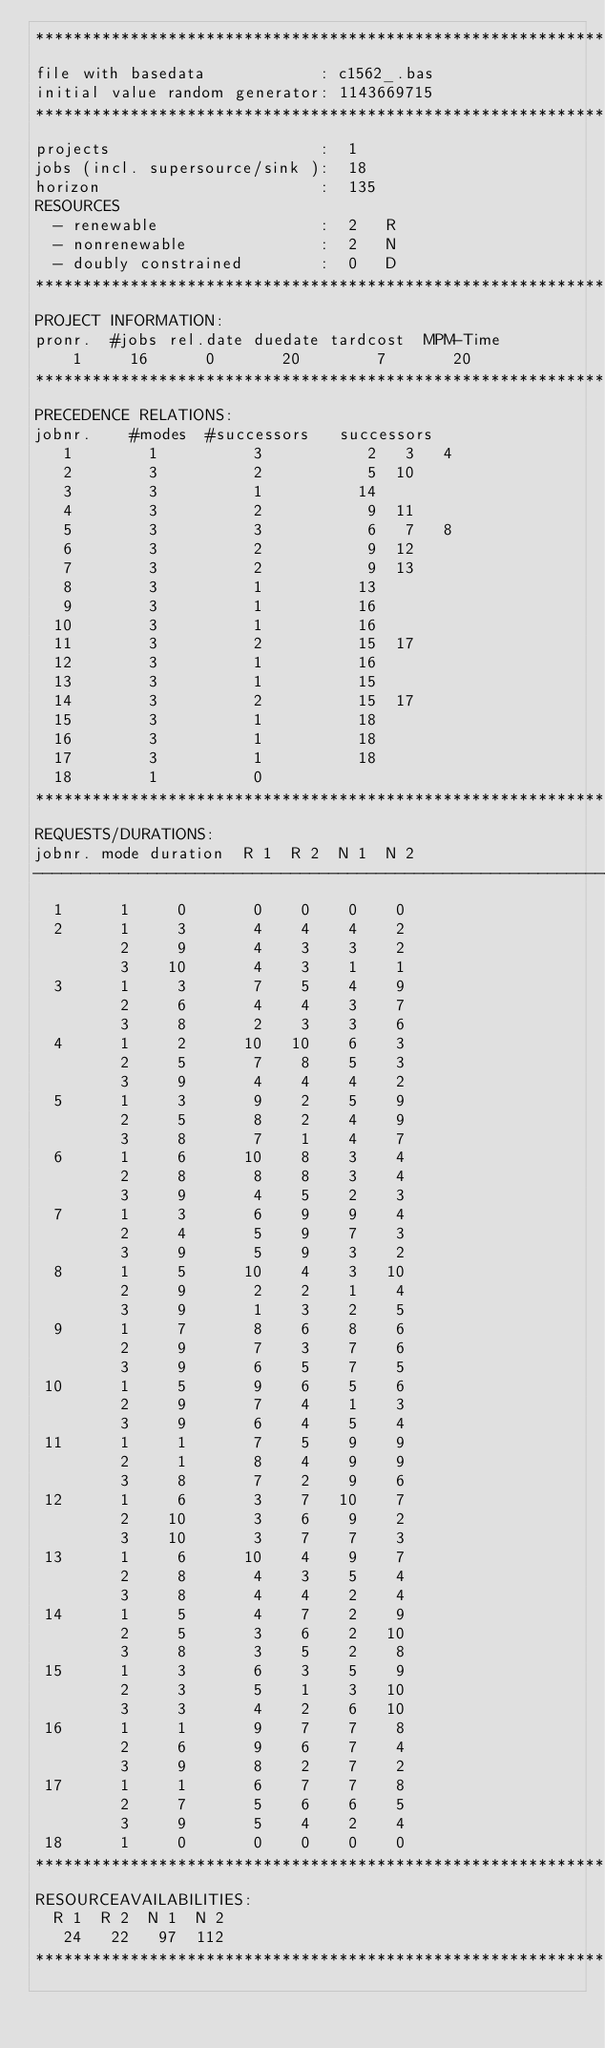<code> <loc_0><loc_0><loc_500><loc_500><_ObjectiveC_>************************************************************************
file with basedata            : c1562_.bas
initial value random generator: 1143669715
************************************************************************
projects                      :  1
jobs (incl. supersource/sink ):  18
horizon                       :  135
RESOURCES
  - renewable                 :  2   R
  - nonrenewable              :  2   N
  - doubly constrained        :  0   D
************************************************************************
PROJECT INFORMATION:
pronr.  #jobs rel.date duedate tardcost  MPM-Time
    1     16      0       20        7       20
************************************************************************
PRECEDENCE RELATIONS:
jobnr.    #modes  #successors   successors
   1        1          3           2   3   4
   2        3          2           5  10
   3        3          1          14
   4        3          2           9  11
   5        3          3           6   7   8
   6        3          2           9  12
   7        3          2           9  13
   8        3          1          13
   9        3          1          16
  10        3          1          16
  11        3          2          15  17
  12        3          1          16
  13        3          1          15
  14        3          2          15  17
  15        3          1          18
  16        3          1          18
  17        3          1          18
  18        1          0        
************************************************************************
REQUESTS/DURATIONS:
jobnr. mode duration  R 1  R 2  N 1  N 2
------------------------------------------------------------------------
  1      1     0       0    0    0    0
  2      1     3       4    4    4    2
         2     9       4    3    3    2
         3    10       4    3    1    1
  3      1     3       7    5    4    9
         2     6       4    4    3    7
         3     8       2    3    3    6
  4      1     2      10   10    6    3
         2     5       7    8    5    3
         3     9       4    4    4    2
  5      1     3       9    2    5    9
         2     5       8    2    4    9
         3     8       7    1    4    7
  6      1     6      10    8    3    4
         2     8       8    8    3    4
         3     9       4    5    2    3
  7      1     3       6    9    9    4
         2     4       5    9    7    3
         3     9       5    9    3    2
  8      1     5      10    4    3   10
         2     9       2    2    1    4
         3     9       1    3    2    5
  9      1     7       8    6    8    6
         2     9       7    3    7    6
         3     9       6    5    7    5
 10      1     5       9    6    5    6
         2     9       7    4    1    3
         3     9       6    4    5    4
 11      1     1       7    5    9    9
         2     1       8    4    9    9
         3     8       7    2    9    6
 12      1     6       3    7   10    7
         2    10       3    6    9    2
         3    10       3    7    7    3
 13      1     6      10    4    9    7
         2     8       4    3    5    4
         3     8       4    4    2    4
 14      1     5       4    7    2    9
         2     5       3    6    2   10
         3     8       3    5    2    8
 15      1     3       6    3    5    9
         2     3       5    1    3   10
         3     3       4    2    6   10
 16      1     1       9    7    7    8
         2     6       9    6    7    4
         3     9       8    2    7    2
 17      1     1       6    7    7    8
         2     7       5    6    6    5
         3     9       5    4    2    4
 18      1     0       0    0    0    0
************************************************************************
RESOURCEAVAILABILITIES:
  R 1  R 2  N 1  N 2
   24   22   97  112
************************************************************************
</code> 